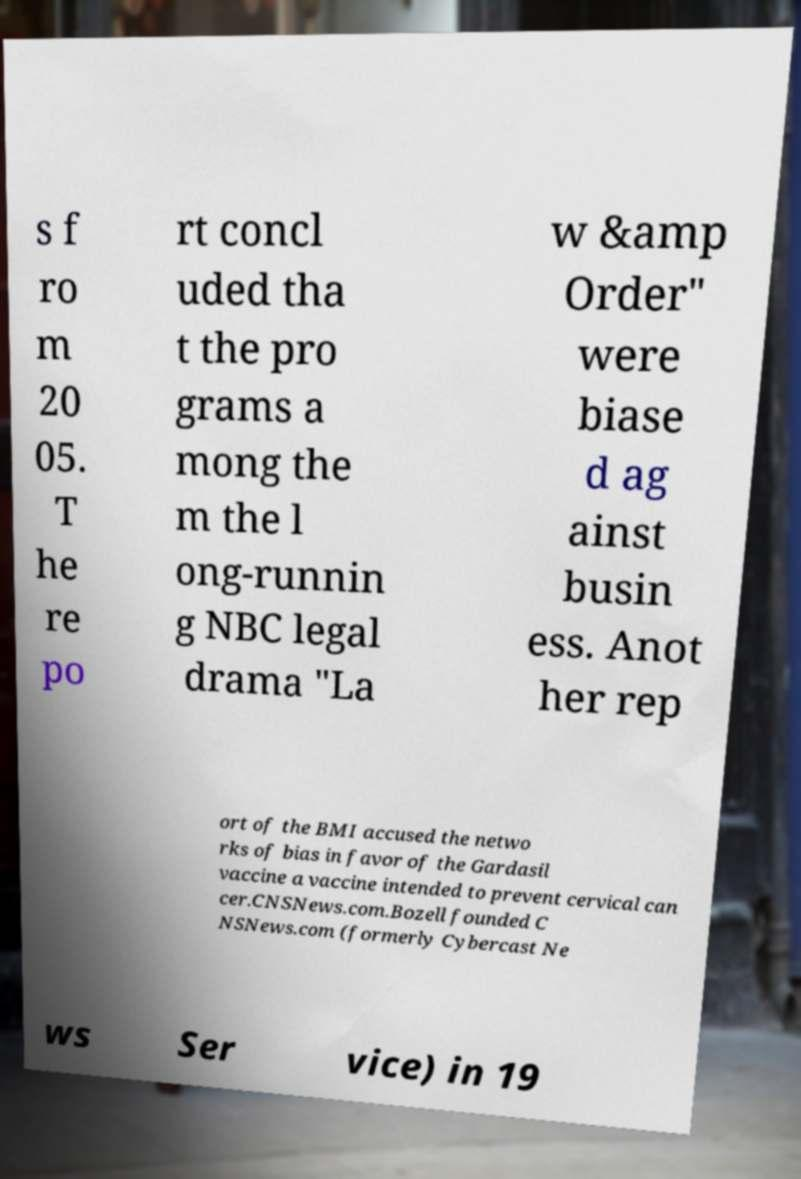Please read and relay the text visible in this image. What does it say? s f ro m 20 05. T he re po rt concl uded tha t the pro grams a mong the m the l ong-runnin g NBC legal drama "La w &amp Order" were biase d ag ainst busin ess. Anot her rep ort of the BMI accused the netwo rks of bias in favor of the Gardasil vaccine a vaccine intended to prevent cervical can cer.CNSNews.com.Bozell founded C NSNews.com (formerly Cybercast Ne ws Ser vice) in 19 